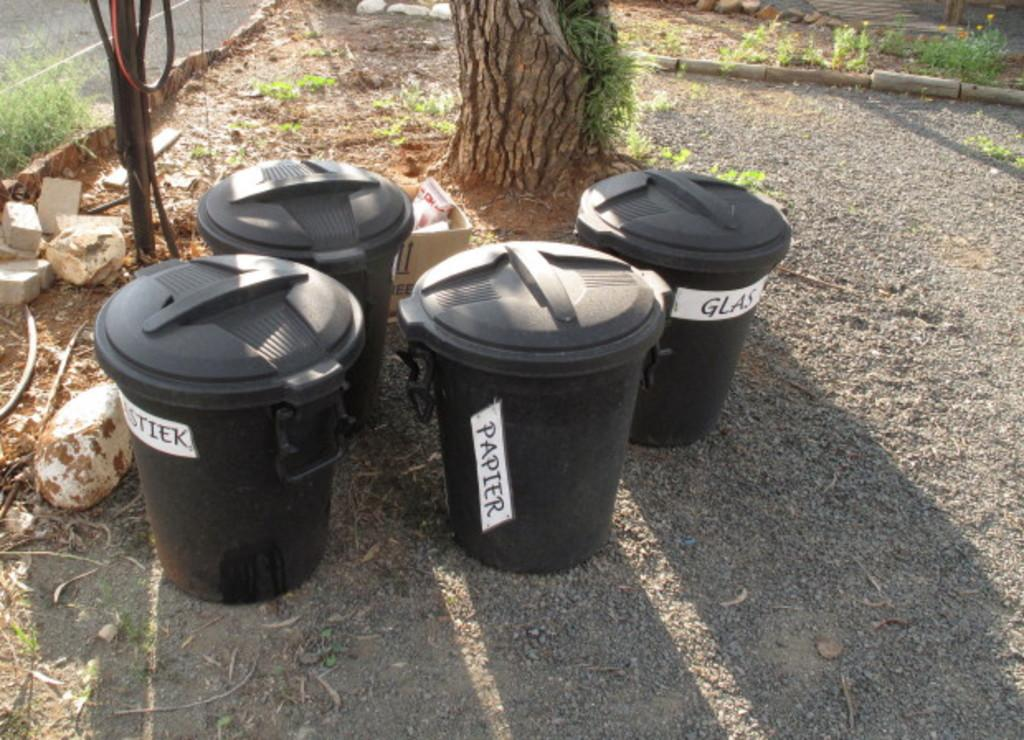<image>
Render a clear and concise summary of the photo. Four plastic recycling cans with lids are sitting outside by a tree and three are labeled Platiek, Papier and Glas. 